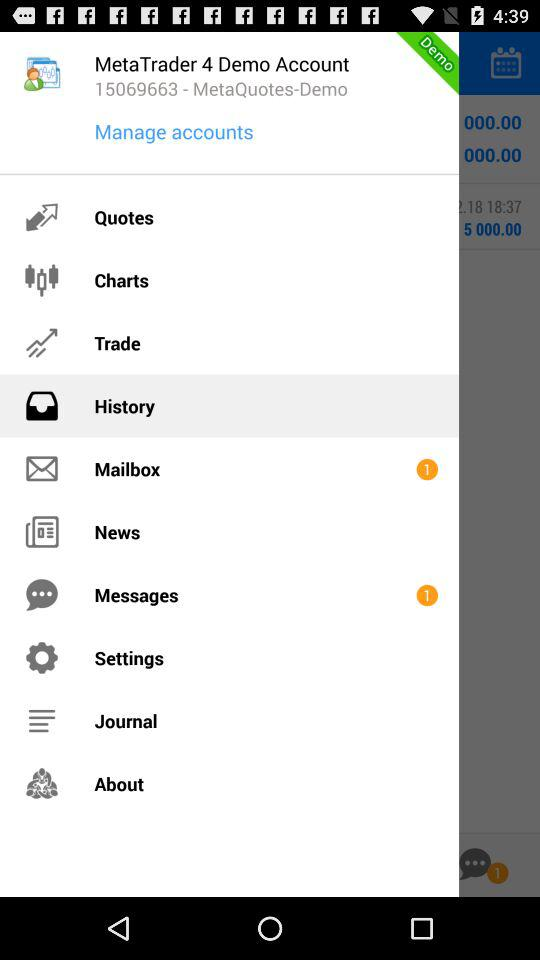How many unread mails are in the mailbox? There is 1 unread mail. 